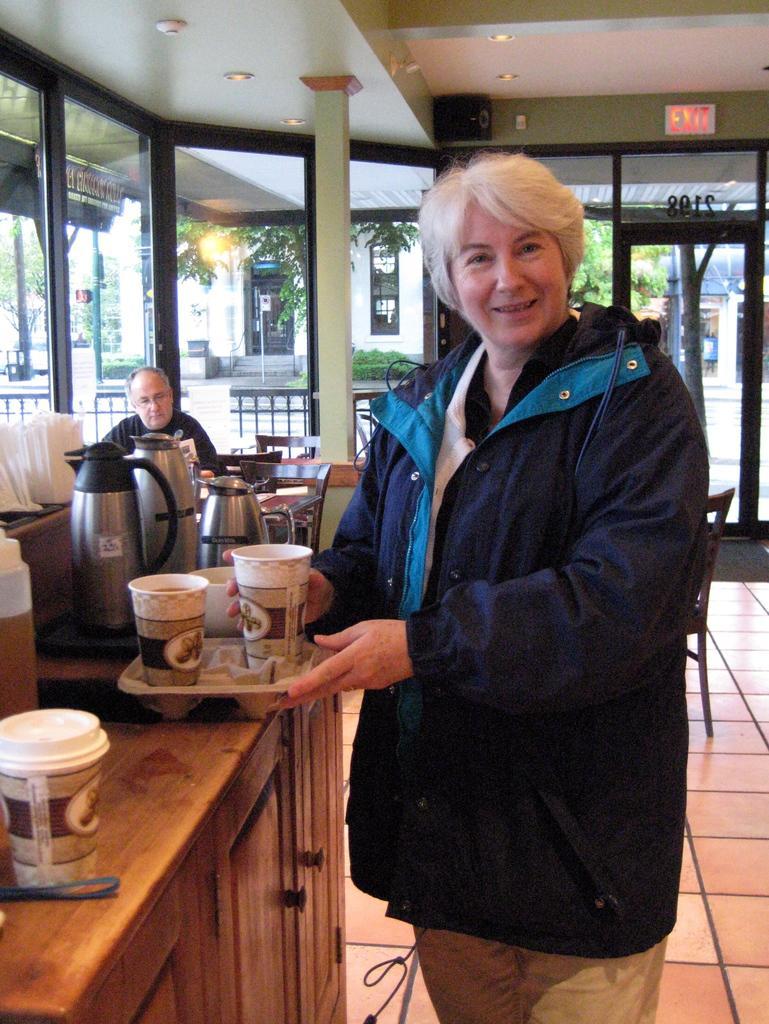Describe this image in one or two sentences. In this image we can see a woman standing and holding a cup. On the left we can see cups, jar and bottle on the top of the wooden shelf. In the background we can see a person sitting in front of the wooden table. We can also see the glass windows. Behind the glass windows we can see a building and also trees. 